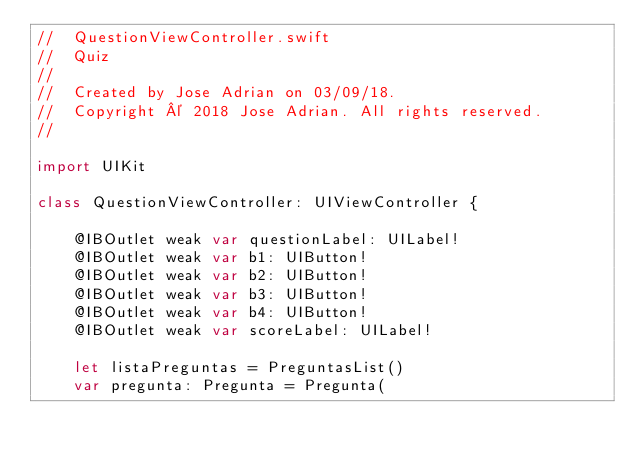Convert code to text. <code><loc_0><loc_0><loc_500><loc_500><_Swift_>//  QuestionViewController.swift
//  Quiz
//
//  Created by Jose Adrian on 03/09/18.
//  Copyright © 2018 Jose Adrian. All rights reserved.
//

import UIKit

class QuestionViewController: UIViewController {

    @IBOutlet weak var questionLabel: UILabel!
    @IBOutlet weak var b1: UIButton!
    @IBOutlet weak var b2: UIButton!
    @IBOutlet weak var b3: UIButton!
    @IBOutlet weak var b4: UIButton!
    @IBOutlet weak var scoreLabel: UILabel!
    
    let listaPreguntas = PreguntasList()
    var pregunta: Pregunta = Pregunta(</code> 